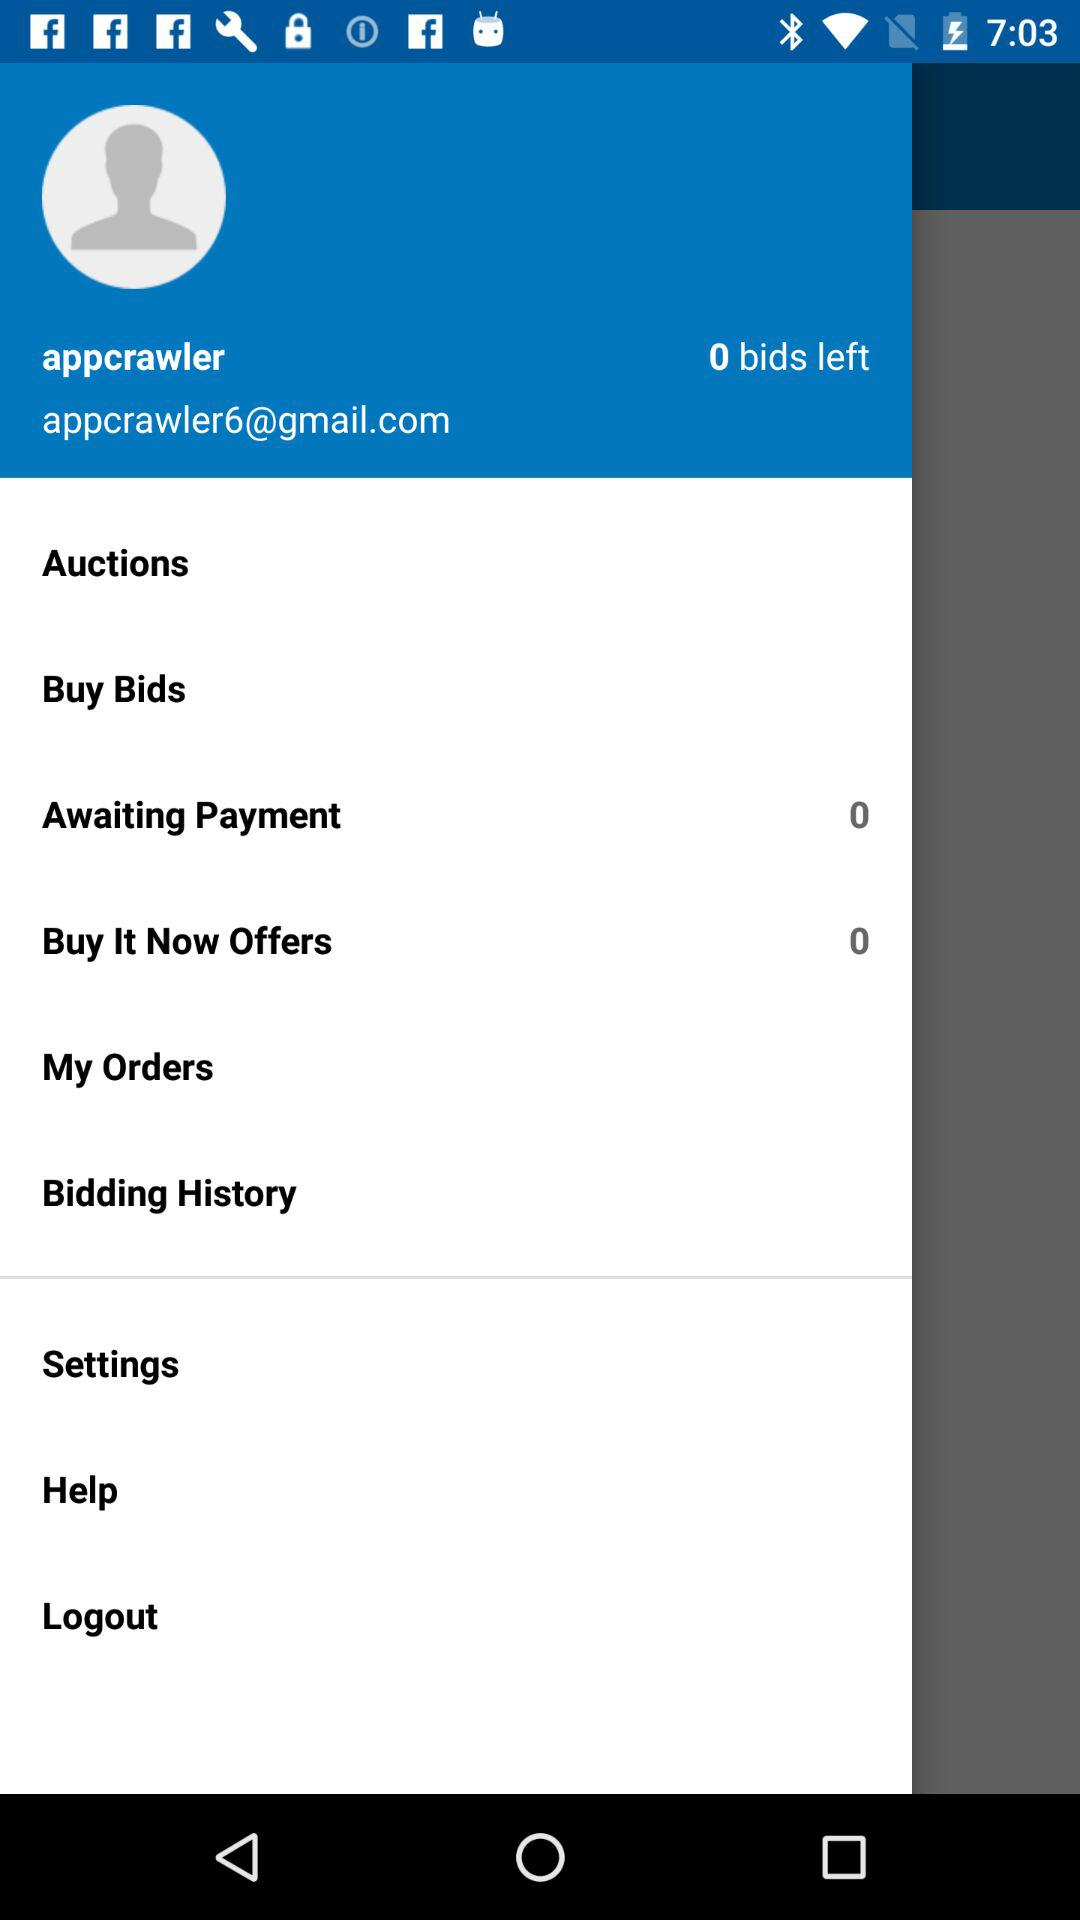What is the user name? The user name is "appcrawler". 